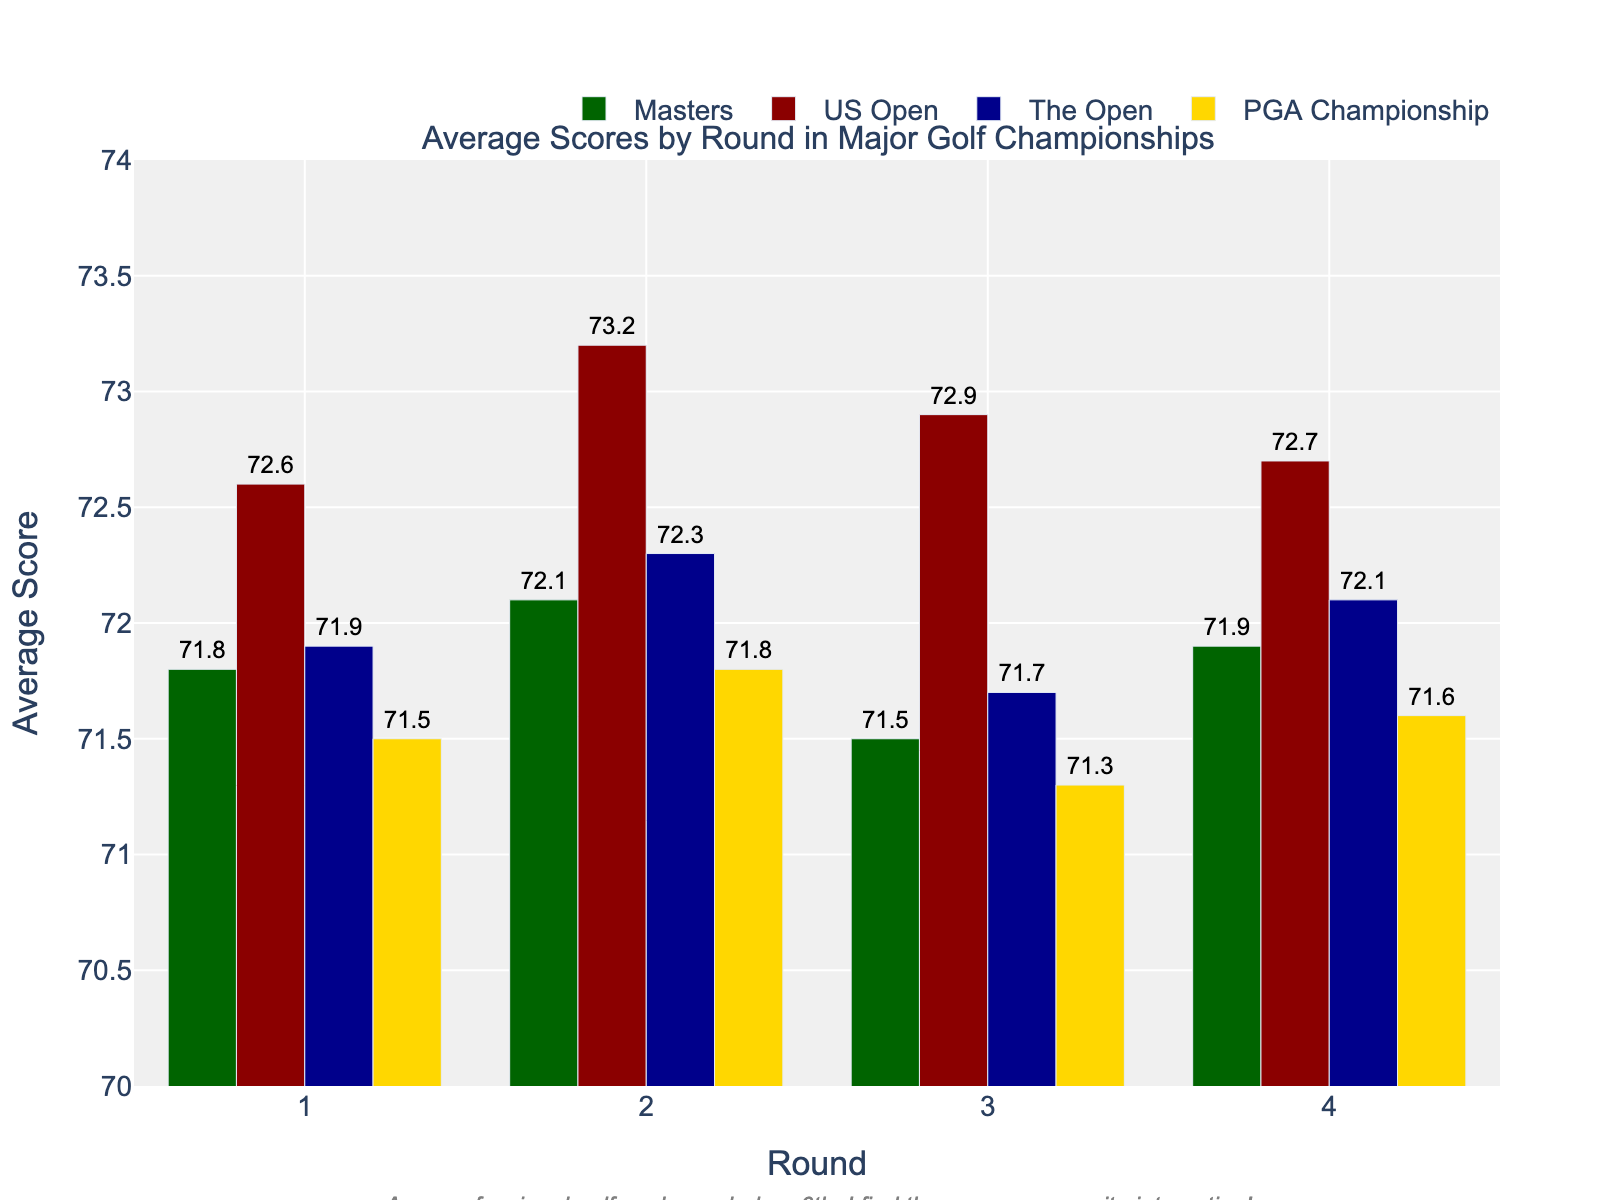What is the average score for Round 1 in the US Open? The bar chart shows the average scores for each round in the US Open. For Round 1, the average score is represented by a bar reaching up to a certain value. We can see that the average score for Round 1 in the US Open is indicated next to the top of the bar.
Answer: 72.6 Which round had the lowest average score in the PGA Championship? To find the lowest average score in the PGA Championship, we need to look at the heights of the bars for the PGA Championship across all rounds. The shortest bar corresponds to Round 3.
Answer: Round 3 How does the average score of Round 2 in The Open compare to Round 2 in the Masters? Compare the heights of the bars for Round 2 in The Open and the Masters. Round 2 in The Open has a bar reaching up to 72.3, while the bar for Round 2 in the Masters reaches up to 72.1. The bar for The Open is slightly higher than that for the Masters, indicating a higher average score.
Answer: Higher What is the total average score for all rounds combined in the Masters? Sum the average scores for all rounds in the Masters from the bar chart: Round 1 (71.8) + Round 2 (72.1) + Round 3 (71.5) + Round 4 (71.9). This results in 71.8 + 72.1 + 71.5 + 71.9 = 287.3.
Answer: 287.3 Which major golf championship had the highest average score in Round 4? Look at the heights of the bars for Round 4 across all major golf championships. The highest bar corresponds to the US Open, which has an average score of 72.7.
Answer: US Open For the US Open, what is the difference between the average scores of Round 2 and Round 4? Subtract the average score of Round 4 from that of Round 2 in the US Open: Round 2 (73.2) - Round 4 (72.7). This results in 73.2 - 72.7 = 0.5.
Answer: 0.5 Which round in the Masters had the lowest average score? Look at the heights of the bars in the Masters for each round. The shortest bar corresponds to Round 3, indicating it had the lowest average score.
Answer: Round 3 What is the average score difference between Round 1 and Round 3 in the PGA Championship? Subtract the average score of Round 3 from that of Round 1 in the PGA Championship: Round 1 (71.5) - Round 3 (71.3). This results in 71.5 - 71.3 = 0.2.
Answer: 0.2 How does the average score for Round 1 in the Masters compare to the average score for Round 1 in The Open? Compare the heights of the bars for Round 1 in the Masters and The Open. The bars for both Round 1 in the Masters and The Open almost reach the same height, with the Masters being slightly lower (71.8 vs. 71.9). This indicates that the average score for Round 1 in the Masters is slightly lower than in The Open.
Answer: Slightly lower 